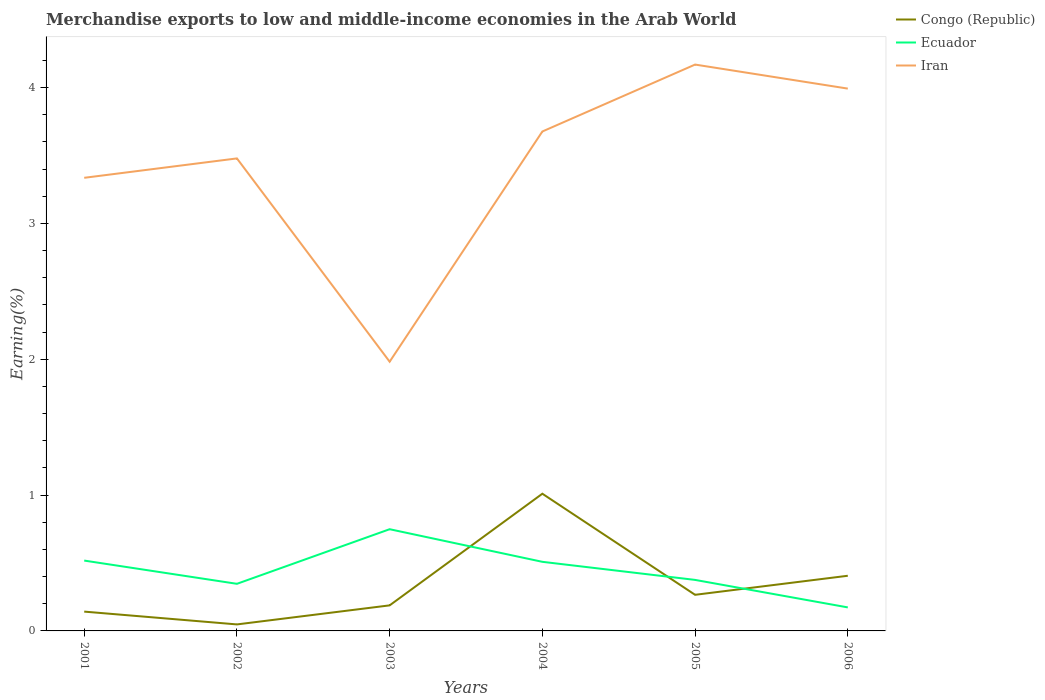How many different coloured lines are there?
Your answer should be compact. 3. Does the line corresponding to Iran intersect with the line corresponding to Ecuador?
Provide a short and direct response. No. Across all years, what is the maximum percentage of amount earned from merchandise exports in Ecuador?
Give a very brief answer. 0.17. What is the total percentage of amount earned from merchandise exports in Congo (Republic) in the graph?
Offer a terse response. 0.6. What is the difference between the highest and the second highest percentage of amount earned from merchandise exports in Iran?
Ensure brevity in your answer.  2.19. Is the percentage of amount earned from merchandise exports in Iran strictly greater than the percentage of amount earned from merchandise exports in Congo (Republic) over the years?
Ensure brevity in your answer.  No. How many lines are there?
Provide a succinct answer. 3. How many years are there in the graph?
Your response must be concise. 6. Are the values on the major ticks of Y-axis written in scientific E-notation?
Ensure brevity in your answer.  No. Where does the legend appear in the graph?
Ensure brevity in your answer.  Top right. How many legend labels are there?
Your answer should be very brief. 3. How are the legend labels stacked?
Your answer should be compact. Vertical. What is the title of the graph?
Your answer should be compact. Merchandise exports to low and middle-income economies in the Arab World. What is the label or title of the X-axis?
Keep it short and to the point. Years. What is the label or title of the Y-axis?
Your response must be concise. Earning(%). What is the Earning(%) in Congo (Republic) in 2001?
Your answer should be very brief. 0.14. What is the Earning(%) of Ecuador in 2001?
Offer a terse response. 0.52. What is the Earning(%) in Iran in 2001?
Offer a very short reply. 3.34. What is the Earning(%) of Congo (Republic) in 2002?
Give a very brief answer. 0.05. What is the Earning(%) of Ecuador in 2002?
Your answer should be very brief. 0.35. What is the Earning(%) of Iran in 2002?
Give a very brief answer. 3.48. What is the Earning(%) of Congo (Republic) in 2003?
Make the answer very short. 0.19. What is the Earning(%) of Ecuador in 2003?
Make the answer very short. 0.75. What is the Earning(%) of Iran in 2003?
Keep it short and to the point. 1.98. What is the Earning(%) of Congo (Republic) in 2004?
Offer a very short reply. 1.01. What is the Earning(%) in Ecuador in 2004?
Offer a terse response. 0.51. What is the Earning(%) of Iran in 2004?
Offer a very short reply. 3.68. What is the Earning(%) in Congo (Republic) in 2005?
Offer a very short reply. 0.27. What is the Earning(%) in Ecuador in 2005?
Offer a very short reply. 0.38. What is the Earning(%) in Iran in 2005?
Your answer should be very brief. 4.17. What is the Earning(%) in Congo (Republic) in 2006?
Your answer should be compact. 0.41. What is the Earning(%) of Ecuador in 2006?
Offer a very short reply. 0.17. What is the Earning(%) of Iran in 2006?
Offer a very short reply. 3.99. Across all years, what is the maximum Earning(%) of Congo (Republic)?
Offer a very short reply. 1.01. Across all years, what is the maximum Earning(%) in Ecuador?
Keep it short and to the point. 0.75. Across all years, what is the maximum Earning(%) of Iran?
Your answer should be very brief. 4.17. Across all years, what is the minimum Earning(%) in Congo (Republic)?
Your response must be concise. 0.05. Across all years, what is the minimum Earning(%) in Ecuador?
Provide a short and direct response. 0.17. Across all years, what is the minimum Earning(%) in Iran?
Offer a terse response. 1.98. What is the total Earning(%) of Congo (Republic) in the graph?
Your answer should be compact. 2.06. What is the total Earning(%) in Ecuador in the graph?
Make the answer very short. 2.67. What is the total Earning(%) of Iran in the graph?
Your answer should be compact. 20.63. What is the difference between the Earning(%) in Congo (Republic) in 2001 and that in 2002?
Make the answer very short. 0.09. What is the difference between the Earning(%) of Ecuador in 2001 and that in 2002?
Provide a short and direct response. 0.17. What is the difference between the Earning(%) of Iran in 2001 and that in 2002?
Provide a short and direct response. -0.14. What is the difference between the Earning(%) of Congo (Republic) in 2001 and that in 2003?
Provide a short and direct response. -0.05. What is the difference between the Earning(%) of Ecuador in 2001 and that in 2003?
Offer a very short reply. -0.23. What is the difference between the Earning(%) in Iran in 2001 and that in 2003?
Your answer should be compact. 1.35. What is the difference between the Earning(%) in Congo (Republic) in 2001 and that in 2004?
Your answer should be very brief. -0.87. What is the difference between the Earning(%) of Ecuador in 2001 and that in 2004?
Give a very brief answer. 0.01. What is the difference between the Earning(%) of Iran in 2001 and that in 2004?
Keep it short and to the point. -0.34. What is the difference between the Earning(%) of Congo (Republic) in 2001 and that in 2005?
Provide a short and direct response. -0.12. What is the difference between the Earning(%) in Ecuador in 2001 and that in 2005?
Offer a terse response. 0.14. What is the difference between the Earning(%) of Iran in 2001 and that in 2005?
Provide a succinct answer. -0.83. What is the difference between the Earning(%) in Congo (Republic) in 2001 and that in 2006?
Keep it short and to the point. -0.26. What is the difference between the Earning(%) of Ecuador in 2001 and that in 2006?
Your answer should be very brief. 0.34. What is the difference between the Earning(%) in Iran in 2001 and that in 2006?
Ensure brevity in your answer.  -0.66. What is the difference between the Earning(%) in Congo (Republic) in 2002 and that in 2003?
Provide a succinct answer. -0.14. What is the difference between the Earning(%) in Ecuador in 2002 and that in 2003?
Your response must be concise. -0.4. What is the difference between the Earning(%) of Iran in 2002 and that in 2003?
Offer a terse response. 1.5. What is the difference between the Earning(%) in Congo (Republic) in 2002 and that in 2004?
Your answer should be very brief. -0.96. What is the difference between the Earning(%) of Ecuador in 2002 and that in 2004?
Your response must be concise. -0.16. What is the difference between the Earning(%) of Iran in 2002 and that in 2004?
Your answer should be compact. -0.2. What is the difference between the Earning(%) of Congo (Republic) in 2002 and that in 2005?
Ensure brevity in your answer.  -0.22. What is the difference between the Earning(%) of Ecuador in 2002 and that in 2005?
Ensure brevity in your answer.  -0.03. What is the difference between the Earning(%) of Iran in 2002 and that in 2005?
Offer a very short reply. -0.69. What is the difference between the Earning(%) of Congo (Republic) in 2002 and that in 2006?
Give a very brief answer. -0.36. What is the difference between the Earning(%) in Ecuador in 2002 and that in 2006?
Provide a succinct answer. 0.17. What is the difference between the Earning(%) of Iran in 2002 and that in 2006?
Your answer should be very brief. -0.51. What is the difference between the Earning(%) in Congo (Republic) in 2003 and that in 2004?
Offer a very short reply. -0.82. What is the difference between the Earning(%) in Ecuador in 2003 and that in 2004?
Offer a terse response. 0.24. What is the difference between the Earning(%) of Iran in 2003 and that in 2004?
Your answer should be compact. -1.69. What is the difference between the Earning(%) of Congo (Republic) in 2003 and that in 2005?
Provide a succinct answer. -0.08. What is the difference between the Earning(%) in Ecuador in 2003 and that in 2005?
Ensure brevity in your answer.  0.37. What is the difference between the Earning(%) of Iran in 2003 and that in 2005?
Offer a very short reply. -2.19. What is the difference between the Earning(%) in Congo (Republic) in 2003 and that in 2006?
Make the answer very short. -0.22. What is the difference between the Earning(%) of Ecuador in 2003 and that in 2006?
Keep it short and to the point. 0.58. What is the difference between the Earning(%) in Iran in 2003 and that in 2006?
Provide a short and direct response. -2.01. What is the difference between the Earning(%) of Congo (Republic) in 2004 and that in 2005?
Ensure brevity in your answer.  0.74. What is the difference between the Earning(%) of Ecuador in 2004 and that in 2005?
Give a very brief answer. 0.13. What is the difference between the Earning(%) in Iran in 2004 and that in 2005?
Offer a very short reply. -0.49. What is the difference between the Earning(%) of Congo (Republic) in 2004 and that in 2006?
Offer a terse response. 0.6. What is the difference between the Earning(%) in Ecuador in 2004 and that in 2006?
Offer a very short reply. 0.34. What is the difference between the Earning(%) in Iran in 2004 and that in 2006?
Provide a succinct answer. -0.32. What is the difference between the Earning(%) in Congo (Republic) in 2005 and that in 2006?
Offer a very short reply. -0.14. What is the difference between the Earning(%) of Ecuador in 2005 and that in 2006?
Provide a short and direct response. 0.2. What is the difference between the Earning(%) in Iran in 2005 and that in 2006?
Offer a very short reply. 0.18. What is the difference between the Earning(%) in Congo (Republic) in 2001 and the Earning(%) in Ecuador in 2002?
Give a very brief answer. -0.2. What is the difference between the Earning(%) of Congo (Republic) in 2001 and the Earning(%) of Iran in 2002?
Give a very brief answer. -3.34. What is the difference between the Earning(%) in Ecuador in 2001 and the Earning(%) in Iran in 2002?
Give a very brief answer. -2.96. What is the difference between the Earning(%) of Congo (Republic) in 2001 and the Earning(%) of Ecuador in 2003?
Offer a terse response. -0.61. What is the difference between the Earning(%) in Congo (Republic) in 2001 and the Earning(%) in Iran in 2003?
Offer a very short reply. -1.84. What is the difference between the Earning(%) of Ecuador in 2001 and the Earning(%) of Iran in 2003?
Give a very brief answer. -1.46. What is the difference between the Earning(%) in Congo (Republic) in 2001 and the Earning(%) in Ecuador in 2004?
Offer a terse response. -0.37. What is the difference between the Earning(%) of Congo (Republic) in 2001 and the Earning(%) of Iran in 2004?
Give a very brief answer. -3.53. What is the difference between the Earning(%) of Ecuador in 2001 and the Earning(%) of Iran in 2004?
Your answer should be very brief. -3.16. What is the difference between the Earning(%) of Congo (Republic) in 2001 and the Earning(%) of Ecuador in 2005?
Keep it short and to the point. -0.23. What is the difference between the Earning(%) in Congo (Republic) in 2001 and the Earning(%) in Iran in 2005?
Provide a succinct answer. -4.03. What is the difference between the Earning(%) of Ecuador in 2001 and the Earning(%) of Iran in 2005?
Your answer should be very brief. -3.65. What is the difference between the Earning(%) of Congo (Republic) in 2001 and the Earning(%) of Ecuador in 2006?
Offer a terse response. -0.03. What is the difference between the Earning(%) in Congo (Republic) in 2001 and the Earning(%) in Iran in 2006?
Offer a terse response. -3.85. What is the difference between the Earning(%) in Ecuador in 2001 and the Earning(%) in Iran in 2006?
Your answer should be very brief. -3.47. What is the difference between the Earning(%) of Congo (Republic) in 2002 and the Earning(%) of Ecuador in 2003?
Ensure brevity in your answer.  -0.7. What is the difference between the Earning(%) of Congo (Republic) in 2002 and the Earning(%) of Iran in 2003?
Offer a terse response. -1.93. What is the difference between the Earning(%) of Ecuador in 2002 and the Earning(%) of Iran in 2003?
Ensure brevity in your answer.  -1.64. What is the difference between the Earning(%) of Congo (Republic) in 2002 and the Earning(%) of Ecuador in 2004?
Keep it short and to the point. -0.46. What is the difference between the Earning(%) in Congo (Republic) in 2002 and the Earning(%) in Iran in 2004?
Provide a succinct answer. -3.63. What is the difference between the Earning(%) in Ecuador in 2002 and the Earning(%) in Iran in 2004?
Your answer should be very brief. -3.33. What is the difference between the Earning(%) of Congo (Republic) in 2002 and the Earning(%) of Ecuador in 2005?
Give a very brief answer. -0.33. What is the difference between the Earning(%) in Congo (Republic) in 2002 and the Earning(%) in Iran in 2005?
Provide a succinct answer. -4.12. What is the difference between the Earning(%) in Ecuador in 2002 and the Earning(%) in Iran in 2005?
Provide a succinct answer. -3.82. What is the difference between the Earning(%) in Congo (Republic) in 2002 and the Earning(%) in Ecuador in 2006?
Ensure brevity in your answer.  -0.13. What is the difference between the Earning(%) in Congo (Republic) in 2002 and the Earning(%) in Iran in 2006?
Your answer should be compact. -3.94. What is the difference between the Earning(%) in Ecuador in 2002 and the Earning(%) in Iran in 2006?
Make the answer very short. -3.65. What is the difference between the Earning(%) of Congo (Republic) in 2003 and the Earning(%) of Ecuador in 2004?
Provide a short and direct response. -0.32. What is the difference between the Earning(%) in Congo (Republic) in 2003 and the Earning(%) in Iran in 2004?
Keep it short and to the point. -3.49. What is the difference between the Earning(%) in Ecuador in 2003 and the Earning(%) in Iran in 2004?
Keep it short and to the point. -2.93. What is the difference between the Earning(%) in Congo (Republic) in 2003 and the Earning(%) in Ecuador in 2005?
Your answer should be compact. -0.19. What is the difference between the Earning(%) in Congo (Republic) in 2003 and the Earning(%) in Iran in 2005?
Offer a very short reply. -3.98. What is the difference between the Earning(%) in Ecuador in 2003 and the Earning(%) in Iran in 2005?
Keep it short and to the point. -3.42. What is the difference between the Earning(%) in Congo (Republic) in 2003 and the Earning(%) in Ecuador in 2006?
Offer a terse response. 0.01. What is the difference between the Earning(%) in Congo (Republic) in 2003 and the Earning(%) in Iran in 2006?
Offer a very short reply. -3.8. What is the difference between the Earning(%) of Ecuador in 2003 and the Earning(%) of Iran in 2006?
Offer a very short reply. -3.24. What is the difference between the Earning(%) of Congo (Republic) in 2004 and the Earning(%) of Ecuador in 2005?
Ensure brevity in your answer.  0.63. What is the difference between the Earning(%) of Congo (Republic) in 2004 and the Earning(%) of Iran in 2005?
Make the answer very short. -3.16. What is the difference between the Earning(%) of Ecuador in 2004 and the Earning(%) of Iran in 2005?
Your answer should be very brief. -3.66. What is the difference between the Earning(%) in Congo (Republic) in 2004 and the Earning(%) in Ecuador in 2006?
Your answer should be very brief. 0.84. What is the difference between the Earning(%) of Congo (Republic) in 2004 and the Earning(%) of Iran in 2006?
Your answer should be compact. -2.98. What is the difference between the Earning(%) of Ecuador in 2004 and the Earning(%) of Iran in 2006?
Your answer should be very brief. -3.48. What is the difference between the Earning(%) of Congo (Republic) in 2005 and the Earning(%) of Ecuador in 2006?
Offer a very short reply. 0.09. What is the difference between the Earning(%) in Congo (Republic) in 2005 and the Earning(%) in Iran in 2006?
Provide a succinct answer. -3.73. What is the difference between the Earning(%) of Ecuador in 2005 and the Earning(%) of Iran in 2006?
Make the answer very short. -3.62. What is the average Earning(%) of Congo (Republic) per year?
Make the answer very short. 0.34. What is the average Earning(%) of Ecuador per year?
Ensure brevity in your answer.  0.45. What is the average Earning(%) of Iran per year?
Keep it short and to the point. 3.44. In the year 2001, what is the difference between the Earning(%) in Congo (Republic) and Earning(%) in Ecuador?
Give a very brief answer. -0.38. In the year 2001, what is the difference between the Earning(%) in Congo (Republic) and Earning(%) in Iran?
Make the answer very short. -3.19. In the year 2001, what is the difference between the Earning(%) of Ecuador and Earning(%) of Iran?
Your response must be concise. -2.82. In the year 2002, what is the difference between the Earning(%) of Congo (Republic) and Earning(%) of Ecuador?
Your response must be concise. -0.3. In the year 2002, what is the difference between the Earning(%) of Congo (Republic) and Earning(%) of Iran?
Offer a terse response. -3.43. In the year 2002, what is the difference between the Earning(%) of Ecuador and Earning(%) of Iran?
Ensure brevity in your answer.  -3.13. In the year 2003, what is the difference between the Earning(%) in Congo (Republic) and Earning(%) in Ecuador?
Make the answer very short. -0.56. In the year 2003, what is the difference between the Earning(%) in Congo (Republic) and Earning(%) in Iran?
Your answer should be compact. -1.79. In the year 2003, what is the difference between the Earning(%) in Ecuador and Earning(%) in Iran?
Give a very brief answer. -1.23. In the year 2004, what is the difference between the Earning(%) in Congo (Republic) and Earning(%) in Ecuador?
Offer a very short reply. 0.5. In the year 2004, what is the difference between the Earning(%) of Congo (Republic) and Earning(%) of Iran?
Make the answer very short. -2.67. In the year 2004, what is the difference between the Earning(%) of Ecuador and Earning(%) of Iran?
Make the answer very short. -3.17. In the year 2005, what is the difference between the Earning(%) of Congo (Republic) and Earning(%) of Ecuador?
Give a very brief answer. -0.11. In the year 2005, what is the difference between the Earning(%) of Congo (Republic) and Earning(%) of Iran?
Offer a very short reply. -3.9. In the year 2005, what is the difference between the Earning(%) in Ecuador and Earning(%) in Iran?
Provide a succinct answer. -3.79. In the year 2006, what is the difference between the Earning(%) of Congo (Republic) and Earning(%) of Ecuador?
Provide a short and direct response. 0.23. In the year 2006, what is the difference between the Earning(%) in Congo (Republic) and Earning(%) in Iran?
Your response must be concise. -3.59. In the year 2006, what is the difference between the Earning(%) of Ecuador and Earning(%) of Iran?
Provide a succinct answer. -3.82. What is the ratio of the Earning(%) in Congo (Republic) in 2001 to that in 2002?
Offer a terse response. 2.97. What is the ratio of the Earning(%) in Ecuador in 2001 to that in 2002?
Your answer should be very brief. 1.49. What is the ratio of the Earning(%) of Iran in 2001 to that in 2002?
Your answer should be very brief. 0.96. What is the ratio of the Earning(%) in Congo (Republic) in 2001 to that in 2003?
Your answer should be very brief. 0.76. What is the ratio of the Earning(%) in Ecuador in 2001 to that in 2003?
Provide a short and direct response. 0.69. What is the ratio of the Earning(%) of Iran in 2001 to that in 2003?
Your answer should be very brief. 1.68. What is the ratio of the Earning(%) of Congo (Republic) in 2001 to that in 2004?
Your answer should be compact. 0.14. What is the ratio of the Earning(%) of Ecuador in 2001 to that in 2004?
Your answer should be compact. 1.02. What is the ratio of the Earning(%) of Iran in 2001 to that in 2004?
Offer a very short reply. 0.91. What is the ratio of the Earning(%) in Congo (Republic) in 2001 to that in 2005?
Ensure brevity in your answer.  0.53. What is the ratio of the Earning(%) in Ecuador in 2001 to that in 2005?
Ensure brevity in your answer.  1.38. What is the ratio of the Earning(%) in Iran in 2001 to that in 2005?
Make the answer very short. 0.8. What is the ratio of the Earning(%) of Congo (Republic) in 2001 to that in 2006?
Provide a short and direct response. 0.35. What is the ratio of the Earning(%) of Ecuador in 2001 to that in 2006?
Provide a succinct answer. 2.99. What is the ratio of the Earning(%) in Iran in 2001 to that in 2006?
Your answer should be compact. 0.84. What is the ratio of the Earning(%) in Congo (Republic) in 2002 to that in 2003?
Your response must be concise. 0.25. What is the ratio of the Earning(%) in Ecuador in 2002 to that in 2003?
Your answer should be very brief. 0.46. What is the ratio of the Earning(%) of Iran in 2002 to that in 2003?
Offer a terse response. 1.76. What is the ratio of the Earning(%) in Congo (Republic) in 2002 to that in 2004?
Ensure brevity in your answer.  0.05. What is the ratio of the Earning(%) in Ecuador in 2002 to that in 2004?
Ensure brevity in your answer.  0.68. What is the ratio of the Earning(%) of Iran in 2002 to that in 2004?
Give a very brief answer. 0.95. What is the ratio of the Earning(%) in Congo (Republic) in 2002 to that in 2005?
Offer a very short reply. 0.18. What is the ratio of the Earning(%) in Ecuador in 2002 to that in 2005?
Offer a terse response. 0.92. What is the ratio of the Earning(%) of Iran in 2002 to that in 2005?
Give a very brief answer. 0.83. What is the ratio of the Earning(%) of Congo (Republic) in 2002 to that in 2006?
Give a very brief answer. 0.12. What is the ratio of the Earning(%) of Ecuador in 2002 to that in 2006?
Provide a succinct answer. 2. What is the ratio of the Earning(%) of Iran in 2002 to that in 2006?
Your answer should be compact. 0.87. What is the ratio of the Earning(%) of Congo (Republic) in 2003 to that in 2004?
Offer a very short reply. 0.19. What is the ratio of the Earning(%) of Ecuador in 2003 to that in 2004?
Your answer should be very brief. 1.47. What is the ratio of the Earning(%) of Iran in 2003 to that in 2004?
Your response must be concise. 0.54. What is the ratio of the Earning(%) in Congo (Republic) in 2003 to that in 2005?
Offer a very short reply. 0.71. What is the ratio of the Earning(%) in Ecuador in 2003 to that in 2005?
Your answer should be very brief. 1.99. What is the ratio of the Earning(%) of Iran in 2003 to that in 2005?
Provide a short and direct response. 0.48. What is the ratio of the Earning(%) in Congo (Republic) in 2003 to that in 2006?
Provide a succinct answer. 0.46. What is the ratio of the Earning(%) of Ecuador in 2003 to that in 2006?
Offer a very short reply. 4.33. What is the ratio of the Earning(%) in Iran in 2003 to that in 2006?
Your answer should be very brief. 0.5. What is the ratio of the Earning(%) of Congo (Republic) in 2004 to that in 2005?
Make the answer very short. 3.8. What is the ratio of the Earning(%) of Ecuador in 2004 to that in 2005?
Your answer should be very brief. 1.35. What is the ratio of the Earning(%) of Iran in 2004 to that in 2005?
Your response must be concise. 0.88. What is the ratio of the Earning(%) in Congo (Republic) in 2004 to that in 2006?
Offer a very short reply. 2.49. What is the ratio of the Earning(%) of Ecuador in 2004 to that in 2006?
Give a very brief answer. 2.94. What is the ratio of the Earning(%) in Iran in 2004 to that in 2006?
Give a very brief answer. 0.92. What is the ratio of the Earning(%) in Congo (Republic) in 2005 to that in 2006?
Provide a short and direct response. 0.65. What is the ratio of the Earning(%) of Ecuador in 2005 to that in 2006?
Your response must be concise. 2.17. What is the ratio of the Earning(%) in Iran in 2005 to that in 2006?
Ensure brevity in your answer.  1.04. What is the difference between the highest and the second highest Earning(%) of Congo (Republic)?
Provide a succinct answer. 0.6. What is the difference between the highest and the second highest Earning(%) in Ecuador?
Your answer should be very brief. 0.23. What is the difference between the highest and the second highest Earning(%) in Iran?
Your answer should be compact. 0.18. What is the difference between the highest and the lowest Earning(%) of Congo (Republic)?
Give a very brief answer. 0.96. What is the difference between the highest and the lowest Earning(%) of Ecuador?
Provide a succinct answer. 0.58. What is the difference between the highest and the lowest Earning(%) in Iran?
Offer a very short reply. 2.19. 